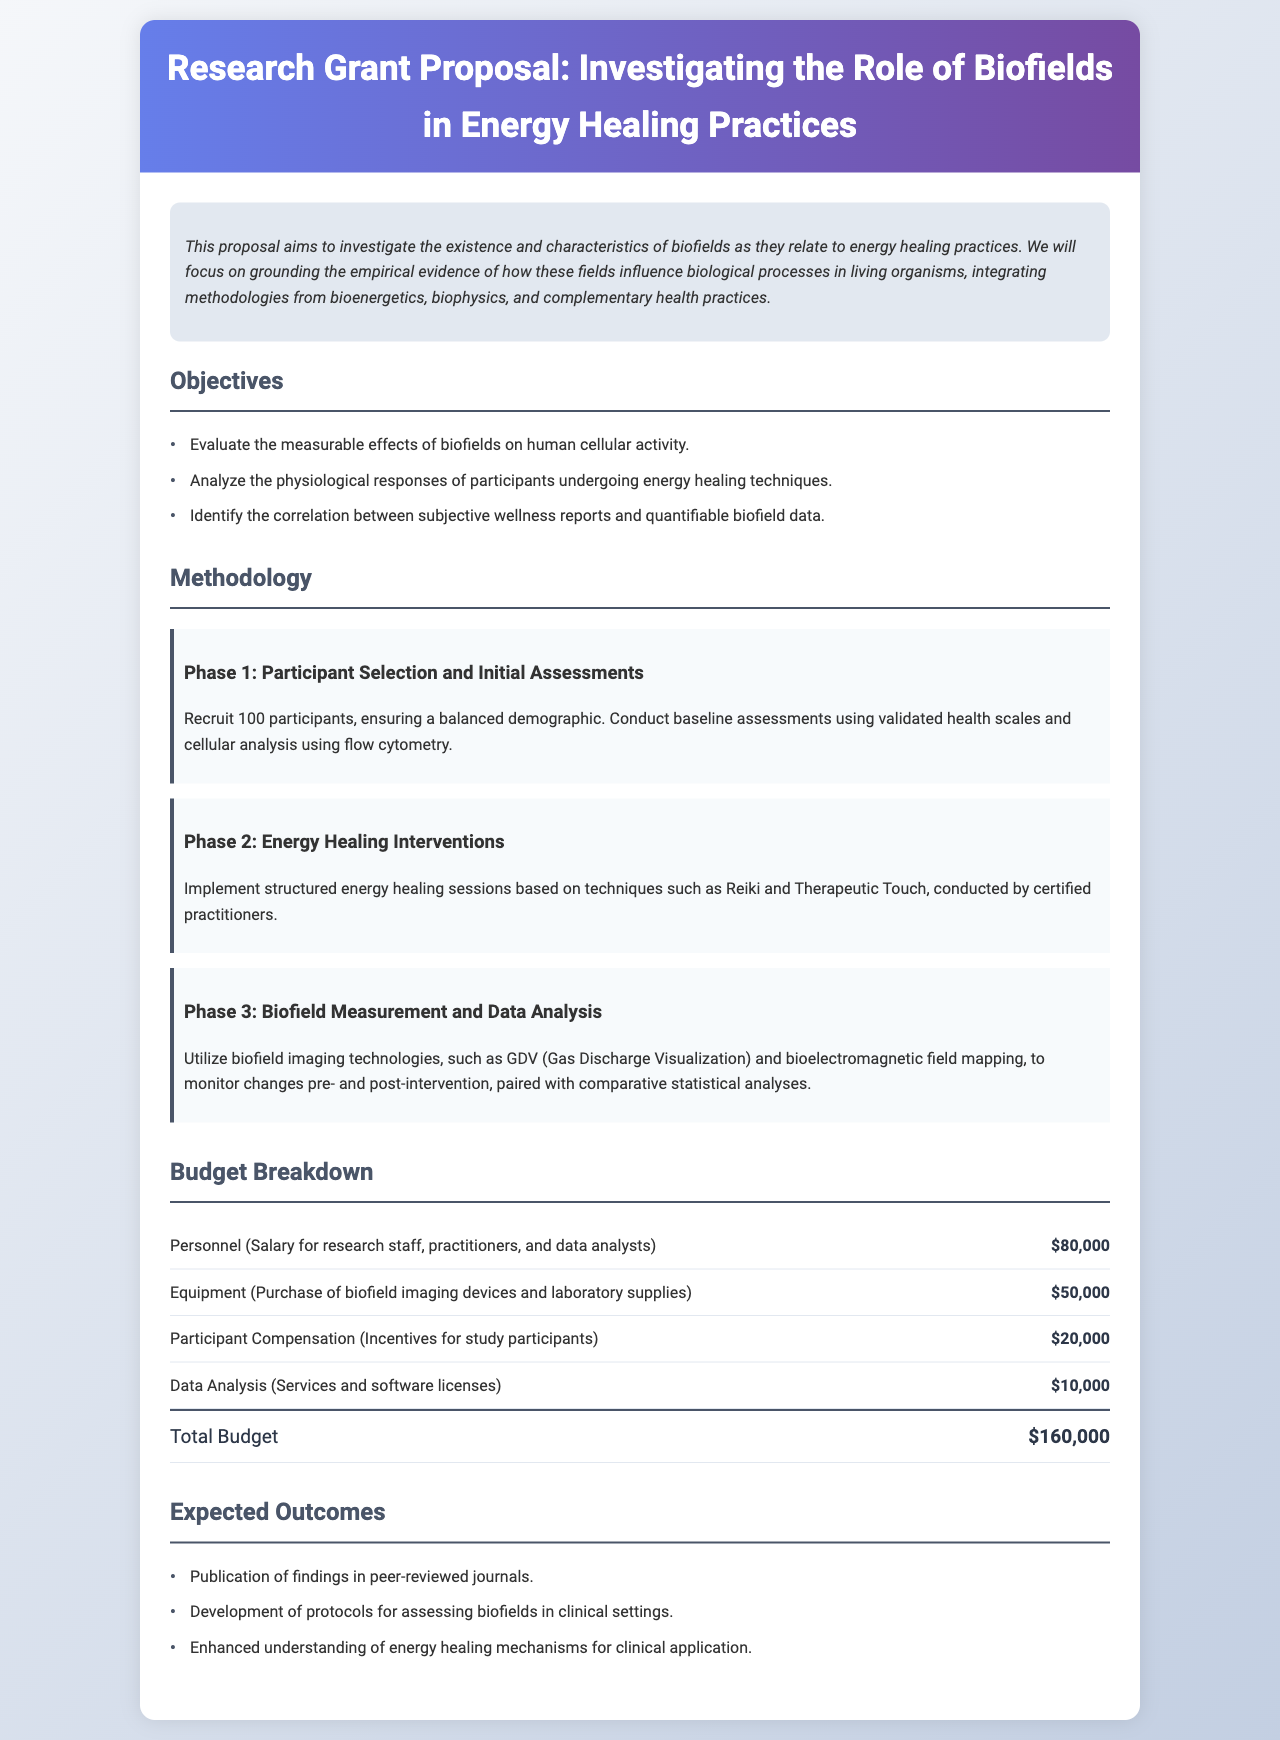What is the total budget for the proposal? The total budget is listed at the end of the budget breakdown section, which totals all budget items.
Answer: $160,000 What is the first objective of the proposal? The first objective is explicitly stated in the objectives section of the document.
Answer: Evaluate the measurable effects of biofields on human cellular activity How many participants will be recruited in Phase 1? The total number of participants is specified in the methodology section under Phase 1.
Answer: 100 What type of technologies will be used to measure biofields? The methodology section describes the specific technologies employed to monitor biofields.
Answer: GDV (Gas Discharge Visualization) and bioelectromagnetic field mapping What is the budget allocated for participant compensation? The budget item for participant compensation is detailed in the budget breakdown section.
Answer: $20,000 What expected outcome relates to clinical settings? The expected outcomes include various results, and one specifically refers to clinical applications.
Answer: Development of protocols for assessing biofields in clinical settings What are the energy healing techniques mentioned in Phase 2? The techniques are listed in the methodology section under Phase 2, explicitly named.
Answer: Reiki and Therapeutic Touch What is the focus of the research proposal? The abstract provides a summary of the main focus of the proposal at the beginning of the document.
Answer: Investigate the existence and characteristics of biofields as they relate to energy healing practices 